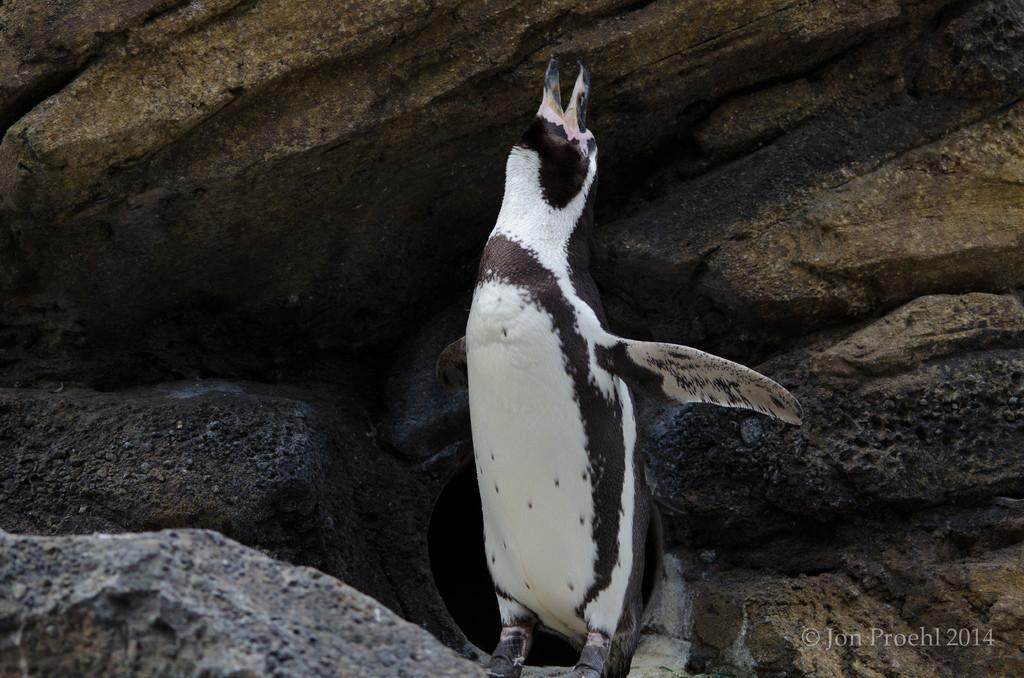What animal is present in the picture? There is a penguin in the picture. What colors can be seen on the penguin? The penguin is white and black in color. What surface is the penguin standing on? The penguin is standing on a rock surface. What can be seen behind the penguin? There are rocks visible behind the penguin. What type of teeth can be seen on the penguin in the image? Penguins do not have teeth, so there are no teeth visible on the penguin in the image. 